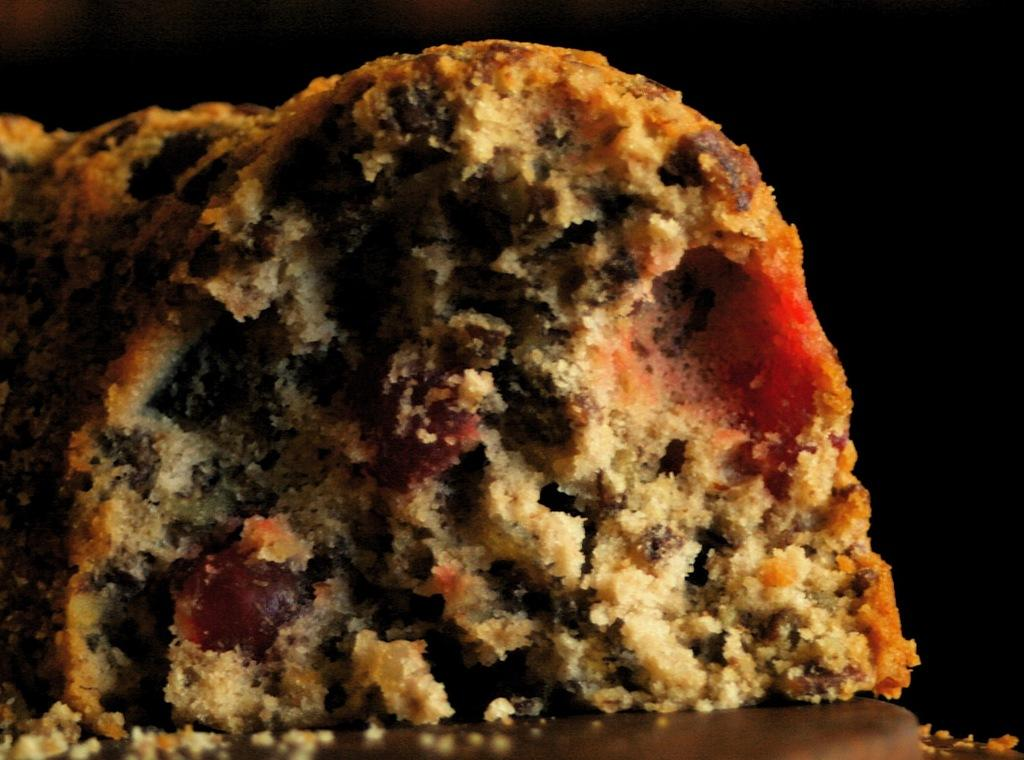What is the main subject of the image? There is a food item in the image. How is the food item presented in the image? The food item is placed on a plate. What type of crook can be seen in the image? There is no crook present in the image; it features a food item placed on a plate. What type of test is being conducted in the image? There is no test being conducted in the image; it features a food item placed on a plate. 